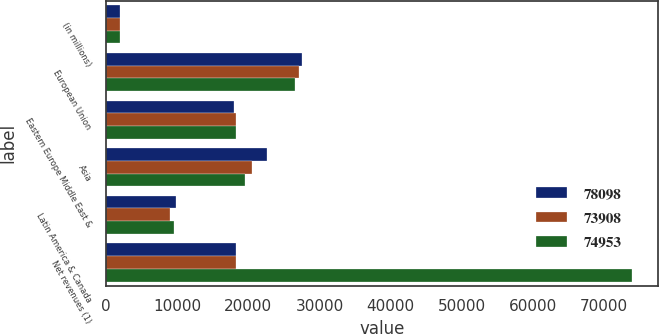<chart> <loc_0><loc_0><loc_500><loc_500><stacked_bar_chart><ecel><fcel>(in millions)<fcel>European Union<fcel>Eastern Europe Middle East &<fcel>Asia<fcel>Latin America & Canada<fcel>Net revenues (1)<nl><fcel>78098<fcel>2017<fcel>27580<fcel>18045<fcel>22635<fcel>9838<fcel>18307<nl><fcel>73908<fcel>2016<fcel>27129<fcel>18286<fcel>20531<fcel>9007<fcel>18307<nl><fcel>74953<fcel>2015<fcel>26563<fcel>18328<fcel>19469<fcel>9548<fcel>73908<nl></chart> 